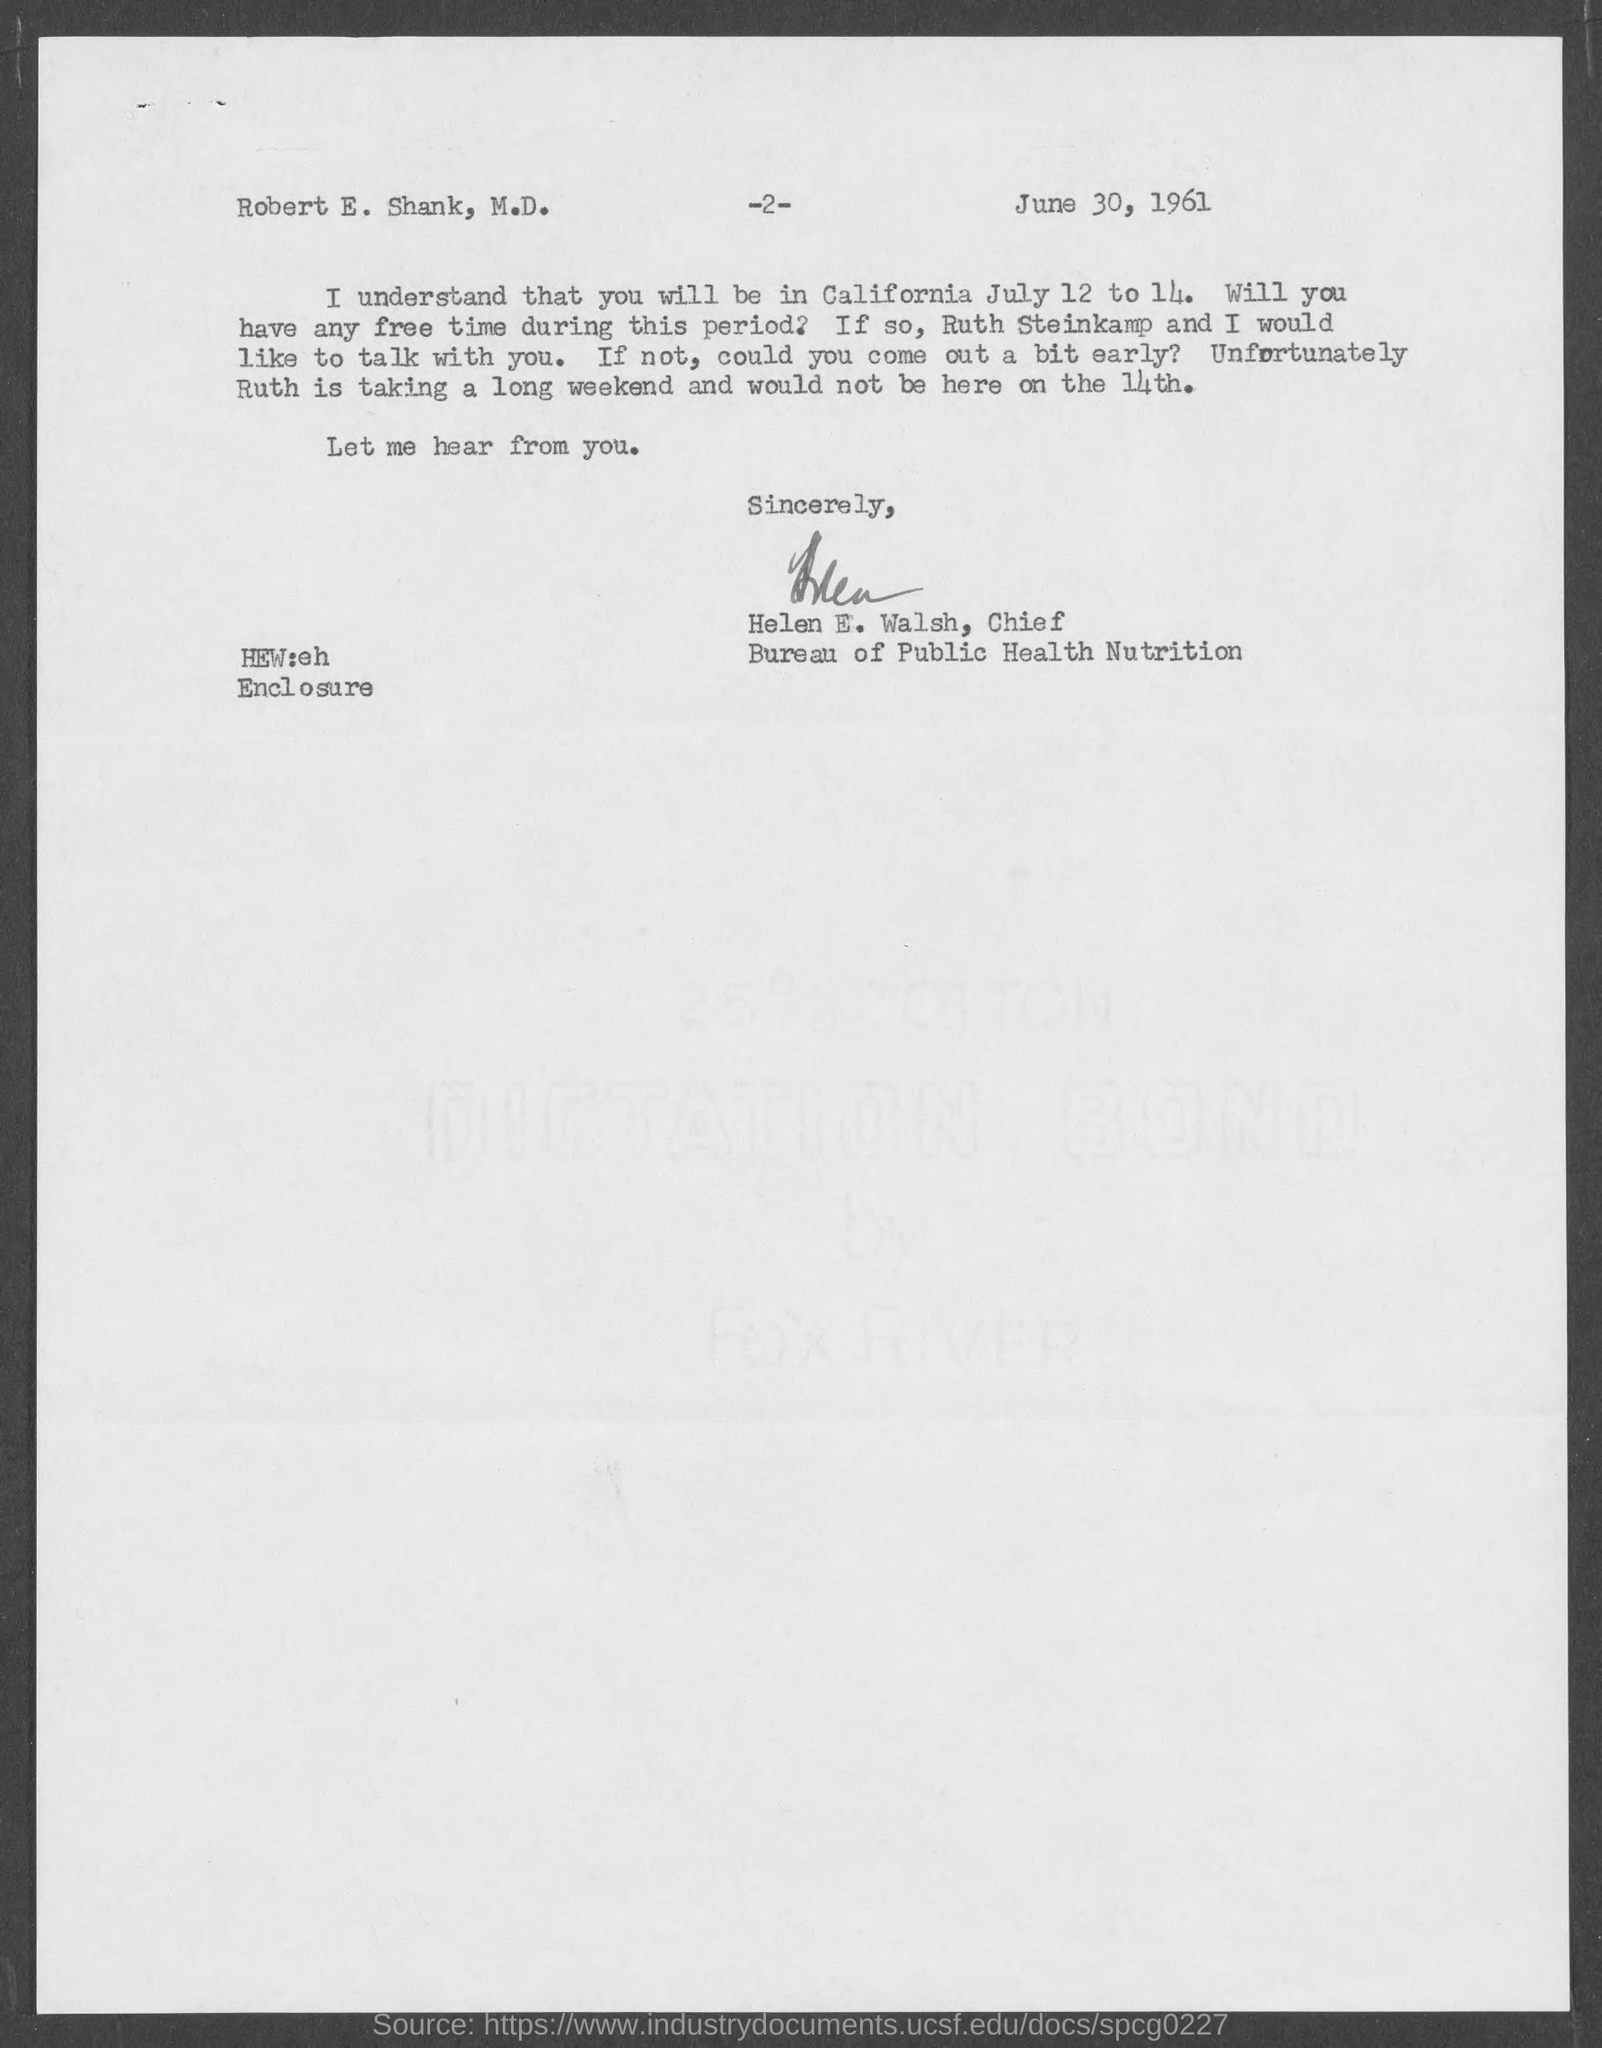Highlight a few significant elements in this photo. The page number at the top of the page is located two pages back. The letter was written by Helen E. Walsh. The letter is dated June 30, 1961. The Bureau of Public Health Nutrition is headed by Helen E. Walsh, who serves as its chief. 